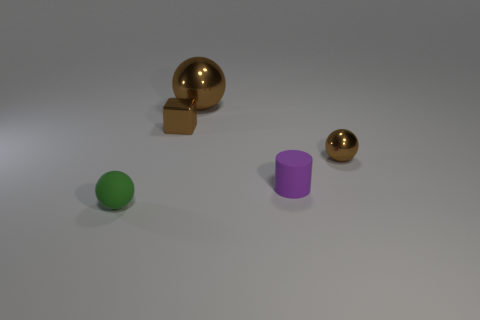What material is the cube?
Keep it short and to the point. Metal. The ball that is behind the green rubber object and in front of the big brown metal object is what color?
Give a very brief answer. Brown. Are there any tiny cylinders behind the small matte ball?
Your response must be concise. Yes. There is a small green matte thing that is on the left side of the small metallic ball; what number of large metal objects are in front of it?
Offer a terse response. 0. There is another brown sphere that is made of the same material as the tiny brown sphere; what size is it?
Your answer should be compact. Large. What is the size of the block?
Ensure brevity in your answer.  Small. Does the small green ball have the same material as the big brown sphere?
Keep it short and to the point. No. What number of blocks are either tiny objects or large brown things?
Give a very brief answer. 1. The small matte object that is right of the ball behind the brown block is what color?
Your answer should be very brief. Purple. What size is the cube that is the same color as the big thing?
Offer a very short reply. Small. 